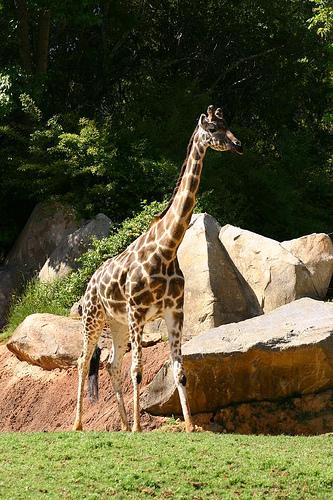Does this animal appear to be in the wild?
Short answer required. No. Is the Giraffe urinating?
Answer briefly. No. Is this in a zoo?
Short answer required. Yes. Is an animal grazing?
Give a very brief answer. No. Is the grass dead?
Concise answer only. No. Is there a rock near the giraffe?
Quick response, please. Yes. Is the giraffe eating?
Quick response, please. No. 